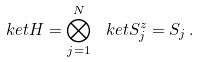Convert formula to latex. <formula><loc_0><loc_0><loc_500><loc_500>\ k e t { H } = \bigotimes _ { j = 1 } ^ { N } \ k e t { S _ { j } ^ { z } = S _ { j } } \, .</formula> 